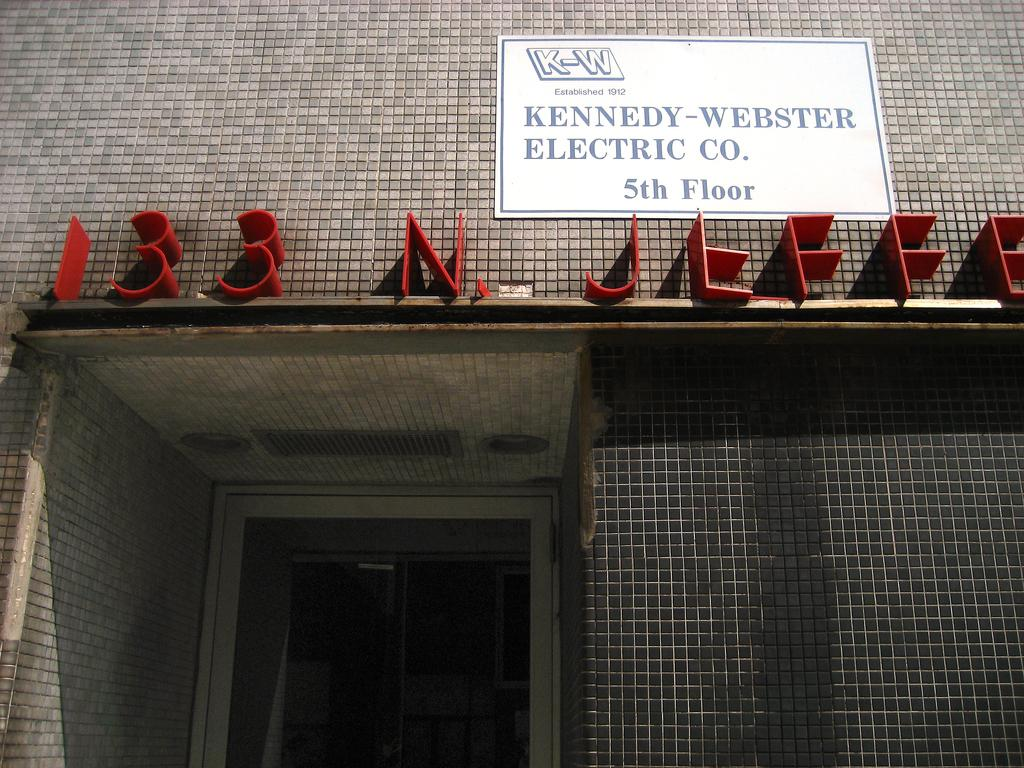What type of structure is visible in the image? There is a building in the image. What can be seen on the wall of the building? There is a board pasted on the wall of the building. What type of bait is being used to catch fish in the image? There is no bait or fishing activity present in the image; it features a building with a board on the wall. Can you describe the locket that is hanging from the wall in the image? There is no locket present in the image; it only features a building with a board on the wall. 